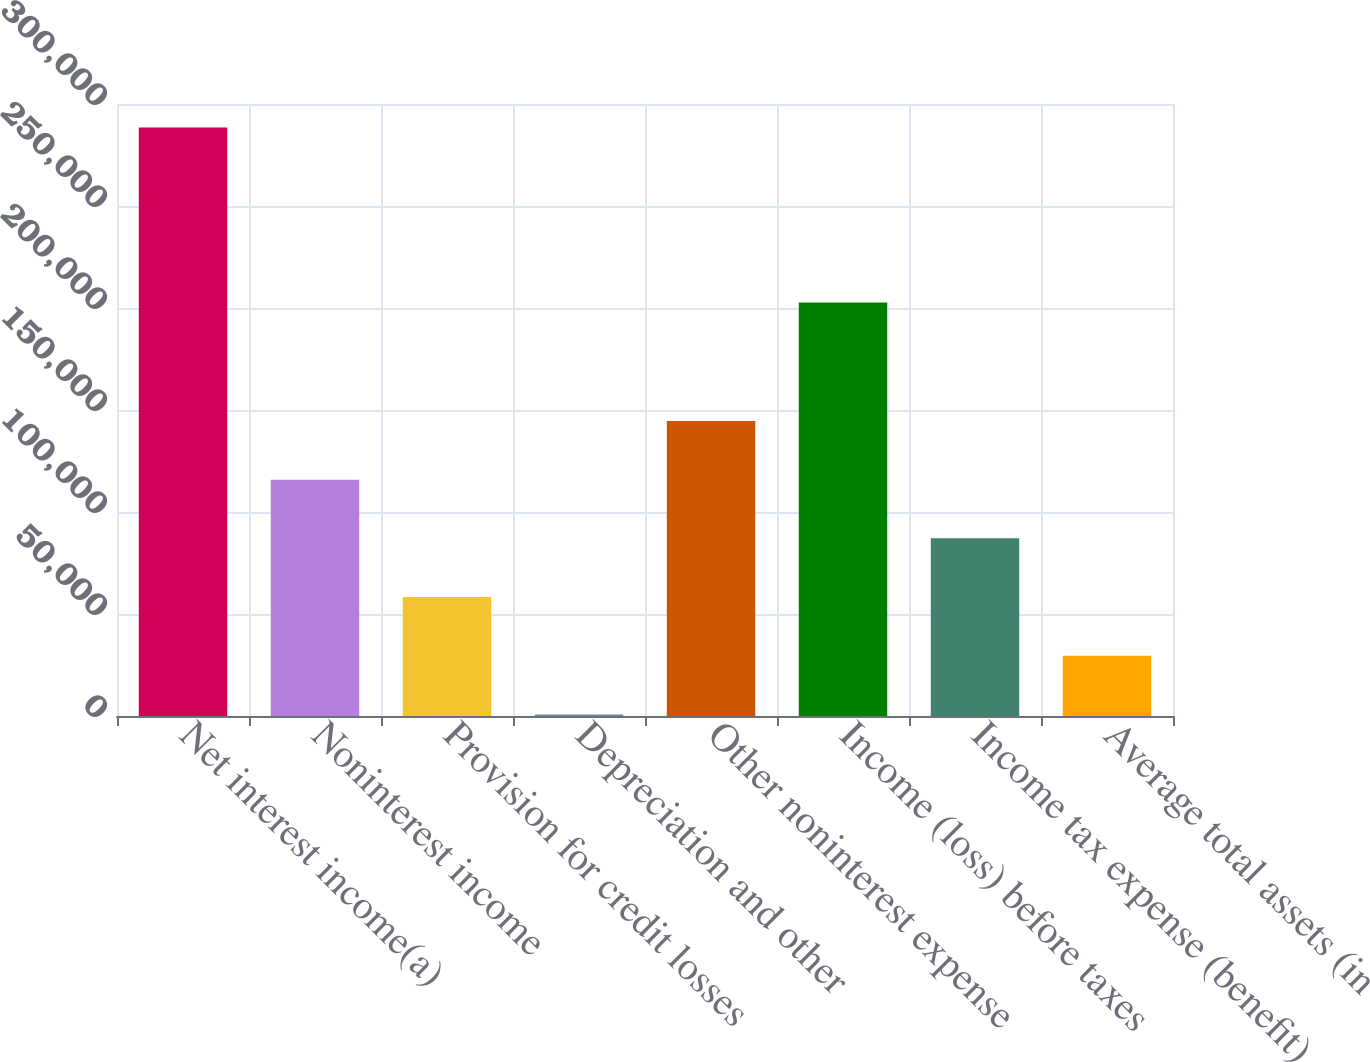<chart> <loc_0><loc_0><loc_500><loc_500><bar_chart><fcel>Net interest income(a)<fcel>Noninterest income<fcel>Provision for credit losses<fcel>Depreciation and other<fcel>Other noninterest expense<fcel>Income (loss) before taxes<fcel>Income tax expense (benefit)<fcel>Average total assets (in<nl><fcel>288519<fcel>115862<fcel>58309.4<fcel>757<fcel>144638<fcel>202746<fcel>87085.6<fcel>29533.2<nl></chart> 